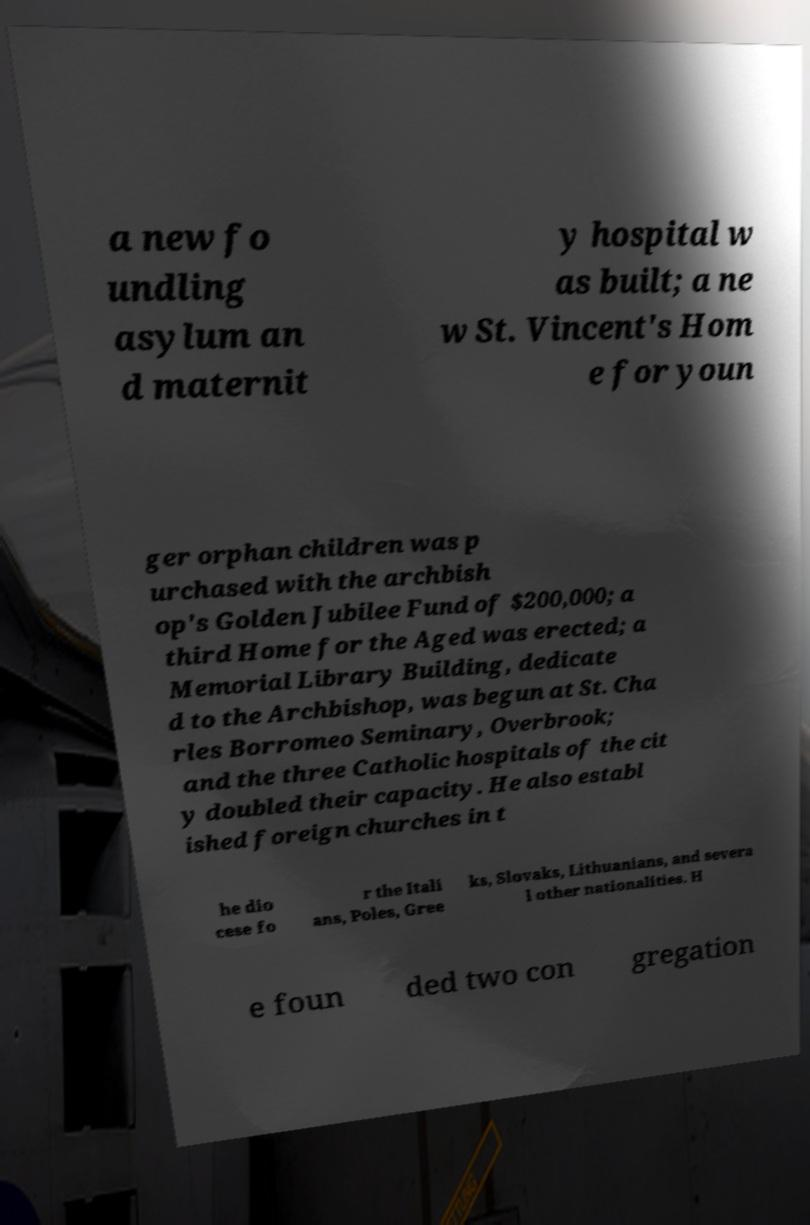Can you read and provide the text displayed in the image?This photo seems to have some interesting text. Can you extract and type it out for me? a new fo undling asylum an d maternit y hospital w as built; a ne w St. Vincent's Hom e for youn ger orphan children was p urchased with the archbish op's Golden Jubilee Fund of $200,000; a third Home for the Aged was erected; a Memorial Library Building, dedicate d to the Archbishop, was begun at St. Cha rles Borromeo Seminary, Overbrook; and the three Catholic hospitals of the cit y doubled their capacity. He also establ ished foreign churches in t he dio cese fo r the Itali ans, Poles, Gree ks, Slovaks, Lithuanians, and severa l other nationalities. H e foun ded two con gregation 